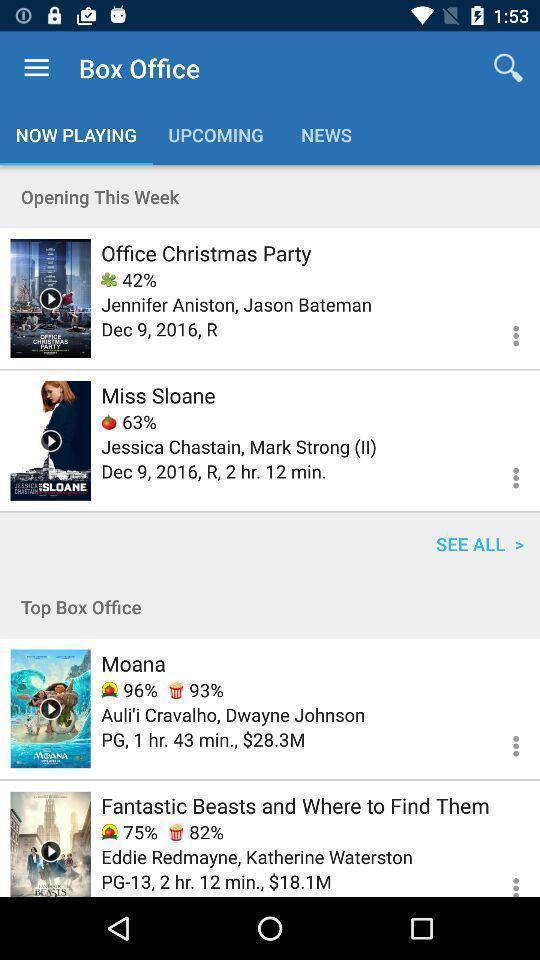Provide a detailed account of this screenshot. Screen shows list of movie options. 